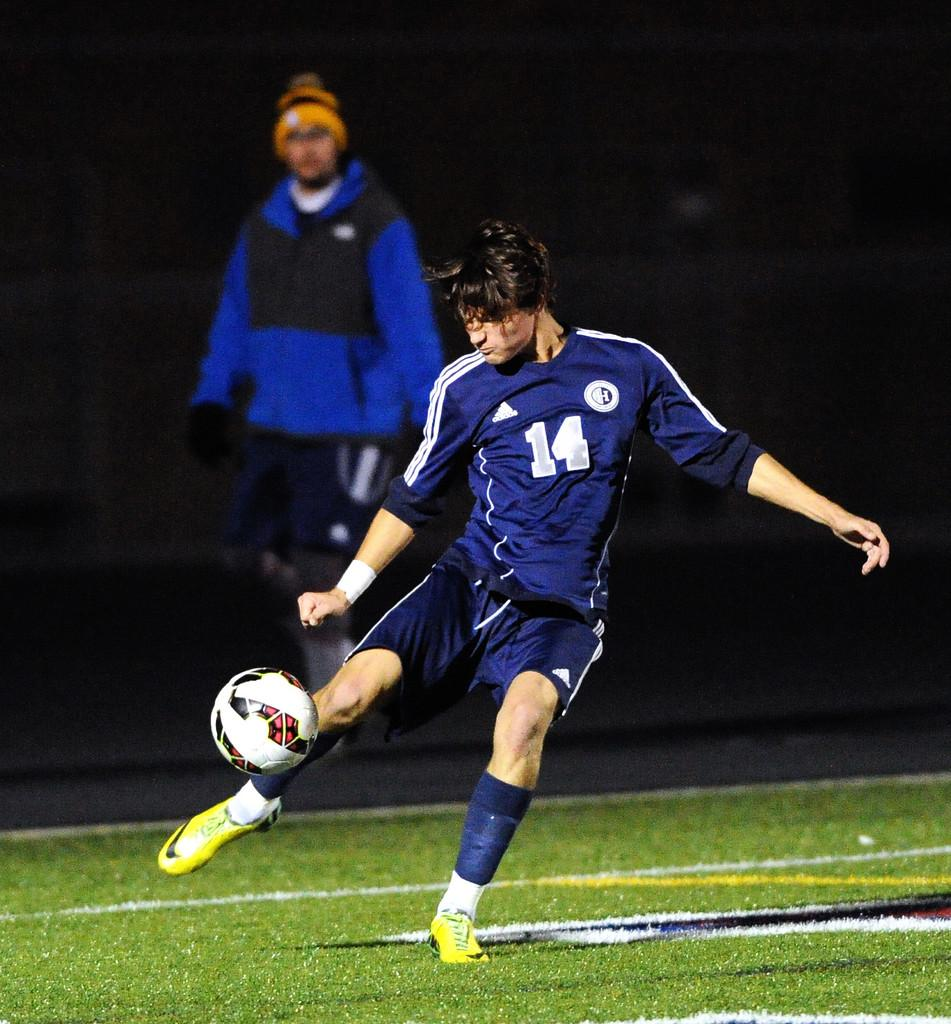<image>
Summarize the visual content of the image. Player number 14 is about to kick the soccer ball. 